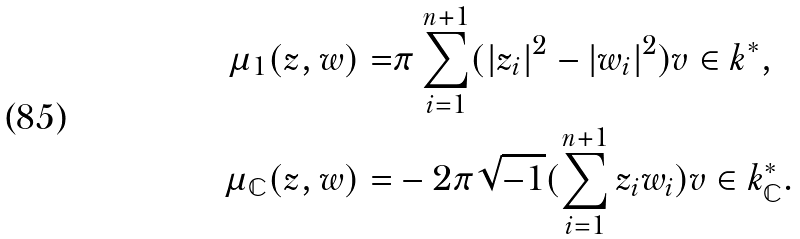Convert formula to latex. <formula><loc_0><loc_0><loc_500><loc_500>\mu _ { 1 } ( z , w ) = & \pi \sum _ { i = 1 } ^ { n + 1 } ( | z _ { i } | ^ { 2 } - | w _ { i } | ^ { 2 } ) v \in k ^ { * } , \\ \mu _ { \mathbb { C } } ( z , w ) = & - 2 \pi \sqrt { - 1 } ( \sum _ { i = 1 } ^ { n + 1 } z _ { i } w _ { i } ) v \in k ^ { * } _ { \mathbb { C } } .</formula> 